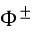Convert formula to latex. <formula><loc_0><loc_0><loc_500><loc_500>\Phi ^ { \pm }</formula> 